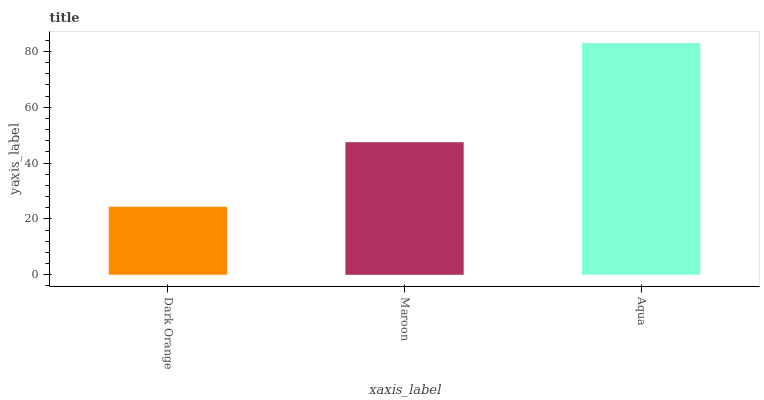Is Maroon the minimum?
Answer yes or no. No. Is Maroon the maximum?
Answer yes or no. No. Is Maroon greater than Dark Orange?
Answer yes or no. Yes. Is Dark Orange less than Maroon?
Answer yes or no. Yes. Is Dark Orange greater than Maroon?
Answer yes or no. No. Is Maroon less than Dark Orange?
Answer yes or no. No. Is Maroon the high median?
Answer yes or no. Yes. Is Maroon the low median?
Answer yes or no. Yes. Is Dark Orange the high median?
Answer yes or no. No. Is Dark Orange the low median?
Answer yes or no. No. 